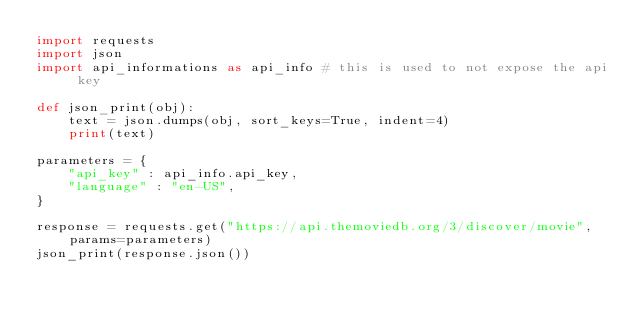Convert code to text. <code><loc_0><loc_0><loc_500><loc_500><_Python_>import requests
import json
import api_informations as api_info # this is used to not expose the api key

def json_print(obj):
    text = json.dumps(obj, sort_keys=True, indent=4)
    print(text)

parameters = {
    "api_key" : api_info.api_key,
    "language" : "en-US",
}

response = requests.get("https://api.themoviedb.org/3/discover/movie", params=parameters)
json_print(response.json())


</code> 